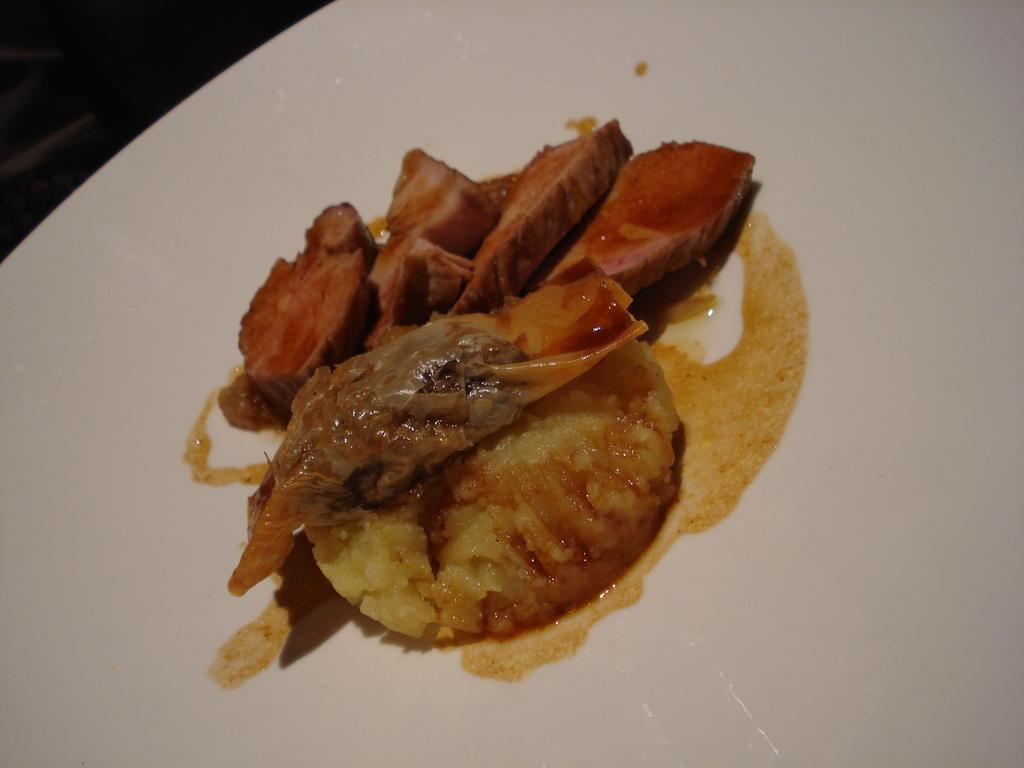Could you give a brief overview of what you see in this image? In this image we can see some food on the plate. There is a white plate in the image. 